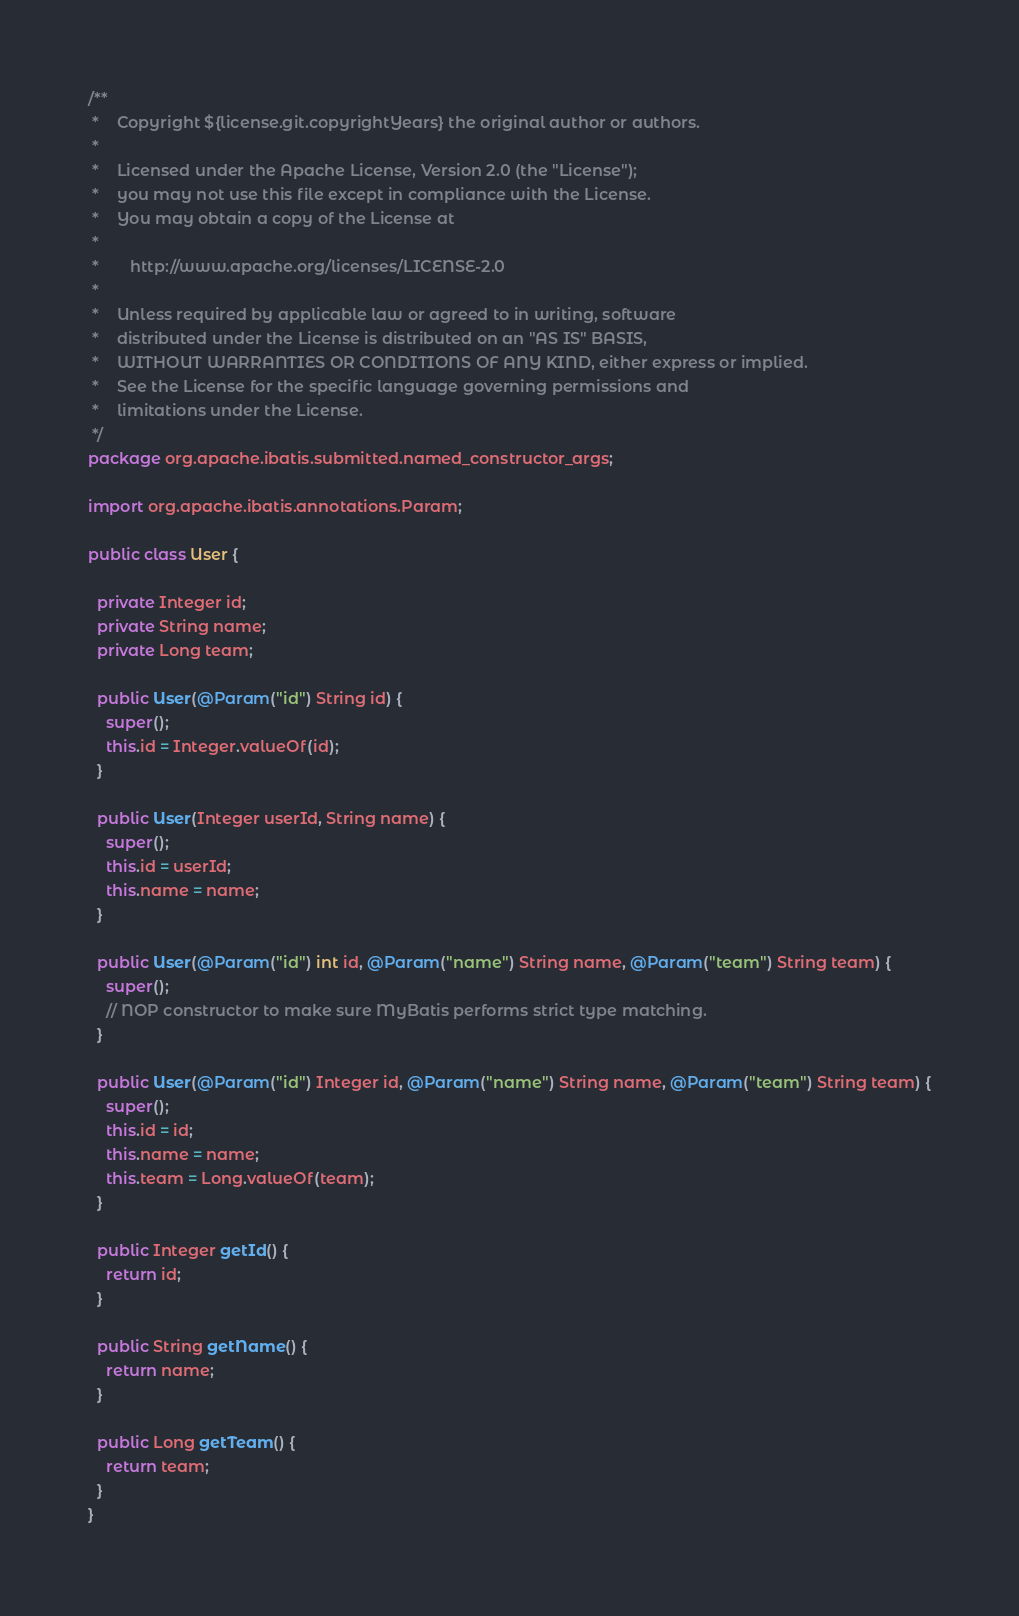<code> <loc_0><loc_0><loc_500><loc_500><_Java_>/**
 *    Copyright ${license.git.copyrightYears} the original author or authors.
 *
 *    Licensed under the Apache License, Version 2.0 (the "License");
 *    you may not use this file except in compliance with the License.
 *    You may obtain a copy of the License at
 *
 *       http://www.apache.org/licenses/LICENSE-2.0
 *
 *    Unless required by applicable law or agreed to in writing, software
 *    distributed under the License is distributed on an "AS IS" BASIS,
 *    WITHOUT WARRANTIES OR CONDITIONS OF ANY KIND, either express or implied.
 *    See the License for the specific language governing permissions and
 *    limitations under the License.
 */
package org.apache.ibatis.submitted.named_constructor_args;

import org.apache.ibatis.annotations.Param;

public class User {

  private Integer id;
  private String name;
  private Long team;

  public User(@Param("id") String id) {
    super();
    this.id = Integer.valueOf(id);
  }

  public User(Integer userId, String name) {
    super();
    this.id = userId;
    this.name = name;
  }

  public User(@Param("id") int id, @Param("name") String name, @Param("team") String team) {
    super();
    // NOP constructor to make sure MyBatis performs strict type matching.
  }

  public User(@Param("id") Integer id, @Param("name") String name, @Param("team") String team) {
    super();
    this.id = id;
    this.name = name;
    this.team = Long.valueOf(team);
  }

  public Integer getId() {
    return id;
  }

  public String getName() {
    return name;
  }

  public Long getTeam() {
    return team;
  }
}
</code> 